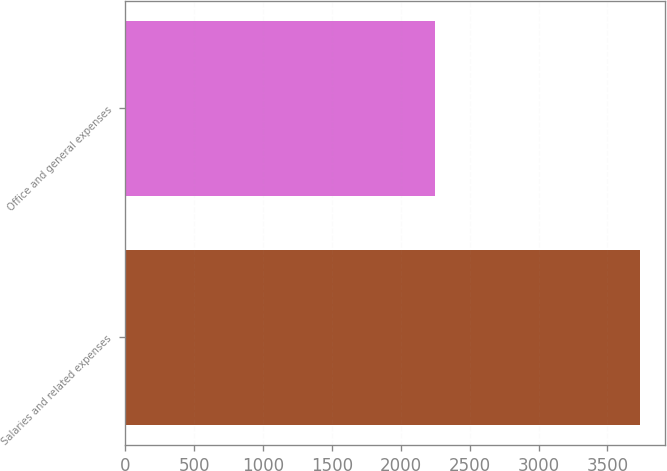<chart> <loc_0><loc_0><loc_500><loc_500><bar_chart><fcel>Salaries and related expenses<fcel>Office and general expenses<nl><fcel>3733<fcel>2250.4<nl></chart> 